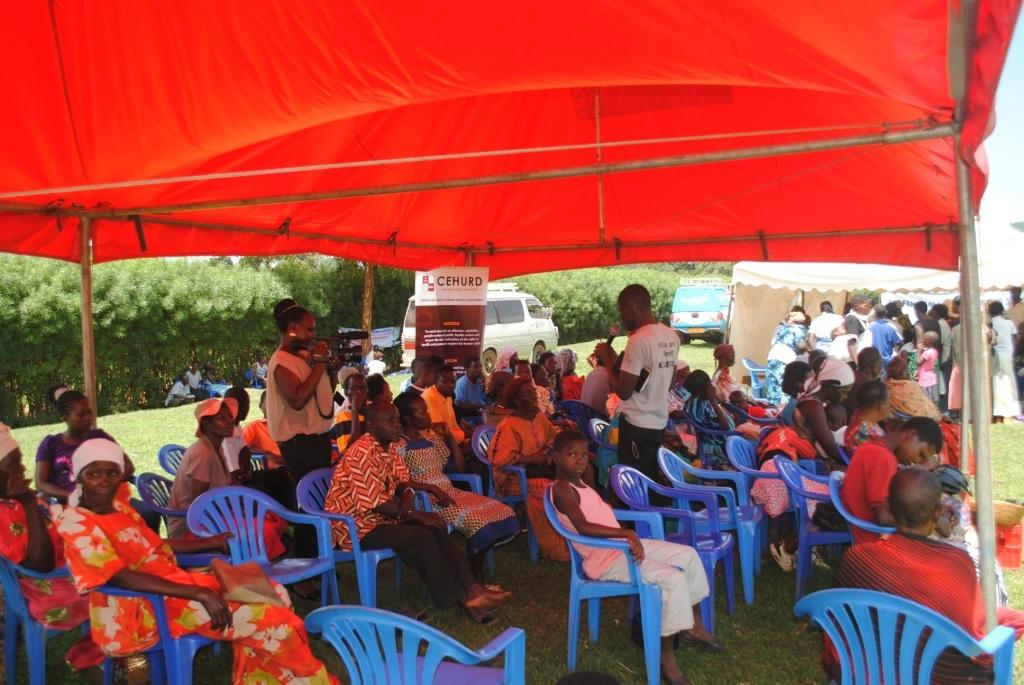Who or what is present in the image? There are people in the image. What are the people sitting on in the image? There are chairs in the image. What type of shelter is visible in the image? There is a tent in the image. What type of transportation can be seen in the image? There are vehicles in the image. What is the ground surface like in the image? Grass is present in the image. What type of vegetation is visible in the image? Trees are visible in the image. What theory is being tested in the image? There is no indication of a theory being tested in the image; it simply shows people, chairs, a tent, vehicles, grass, and trees. 